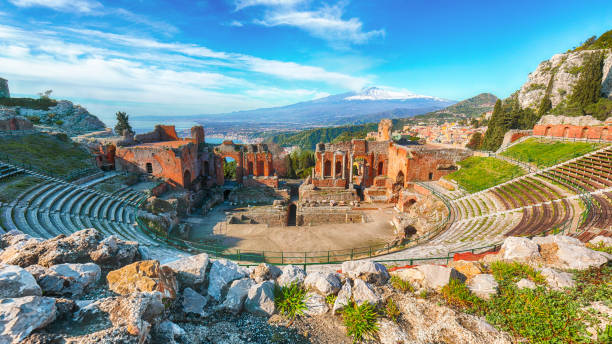Discuss historical significance of the theater in the context of Greek architecture. The ancient Greek theater in Taormina stands as a marvel of Greek architectural ingenuity. The Greeks were pioneers in developing structures that not only served practical purposes but also aesthetic and cultural value. This theater, like many others of its time, was elliptically designed to enhance the viewing experience for spectators and leverage the natural acoustics. Carved into the cliffside, it exemplifies the Greeks' ability to harmonize with the natural landscape, incorporating the panoramic views into the overall experience. The use of local stones not only provided durability but also ensured the theater blended seamlessly with its surroundings. The seating arrangement, structured in a semi-circle, allowed optimal visibility and audio clarity, a testament to the Greeks' understanding of geometry and acoustics. Furthermore, the theater has withstood the test of time, offering insights into the social and cultural lives of ancient Greeks, making it a vital historical and architectural landmark. Analyze the role of natural scenery in enhancing the theater experience. The integration of natural scenery into the Greek theater experience was both intentional and profound. In Taormina, the panoramic views of the Mediterranean Sea and Mount Etna significantly enhance the theater’s allure. The open-air design allowed the audience to not only engage with the performance but also to be enveloped by the natural beauty surrounding them. The expanse of the sea provided a serene backdrop, while the imposing presence of Mount Etna added dramatic grandeur, heightening the emotional impact of the performances. The natural light played upon the stone surfaces, creating shifting patterns of light and shadow that complemented the mood of the plays. This seamless blending of architecture and nature elevated the spectators' experience, making it a multi-sensory event that transcended the performance itself and celebrated the harmony between human creativity and the natural world. 